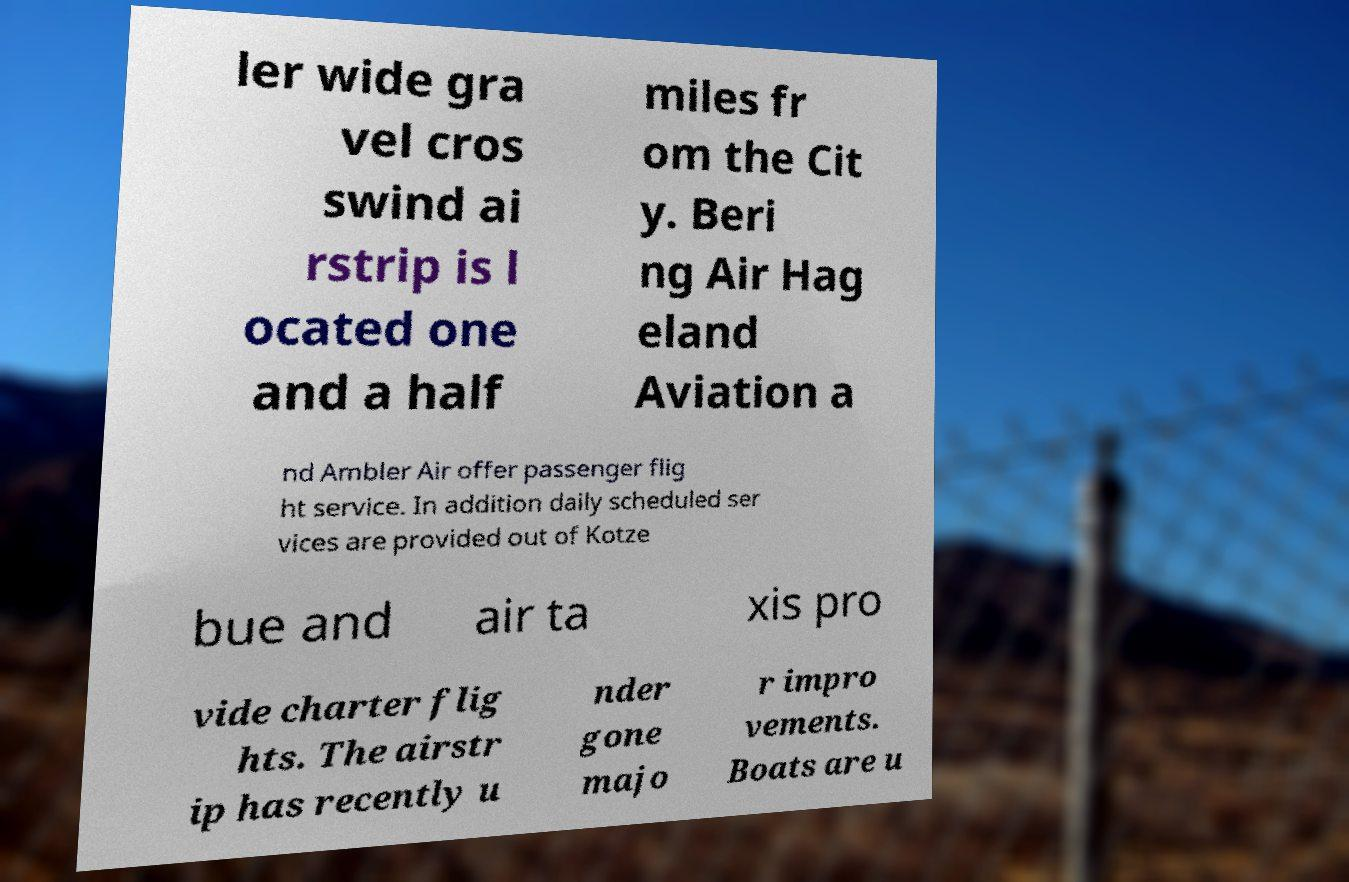Can you read and provide the text displayed in the image?This photo seems to have some interesting text. Can you extract and type it out for me? ler wide gra vel cros swind ai rstrip is l ocated one and a half miles fr om the Cit y. Beri ng Air Hag eland Aviation a nd Ambler Air offer passenger flig ht service. In addition daily scheduled ser vices are provided out of Kotze bue and air ta xis pro vide charter flig hts. The airstr ip has recently u nder gone majo r impro vements. Boats are u 